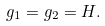<formula> <loc_0><loc_0><loc_500><loc_500>g _ { 1 } = g _ { 2 } = H .</formula> 